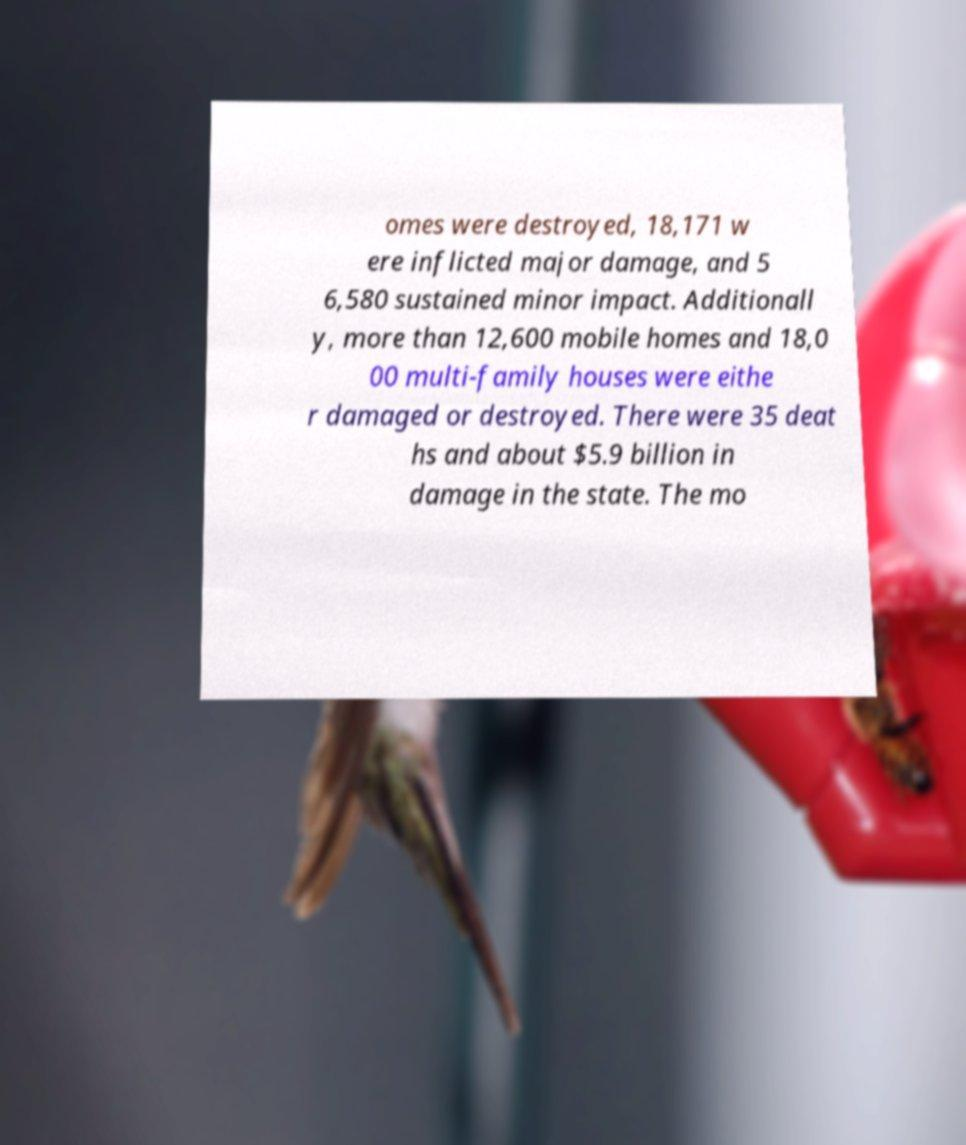Could you assist in decoding the text presented in this image and type it out clearly? omes were destroyed, 18,171 w ere inflicted major damage, and 5 6,580 sustained minor impact. Additionall y, more than 12,600 mobile homes and 18,0 00 multi-family houses were eithe r damaged or destroyed. There were 35 deat hs and about $5.9 billion in damage in the state. The mo 